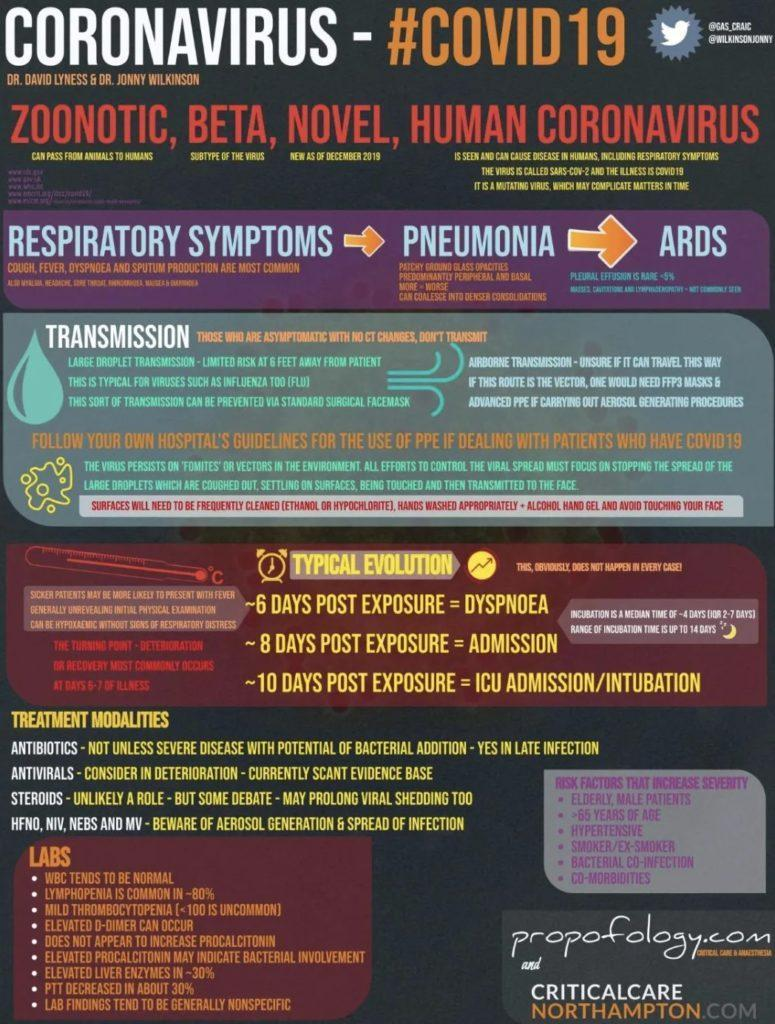Which one is the subtype of the virus?
Answer the question with a short phrase. Beta Which virus can pass from animals to humans? Zoonotic 